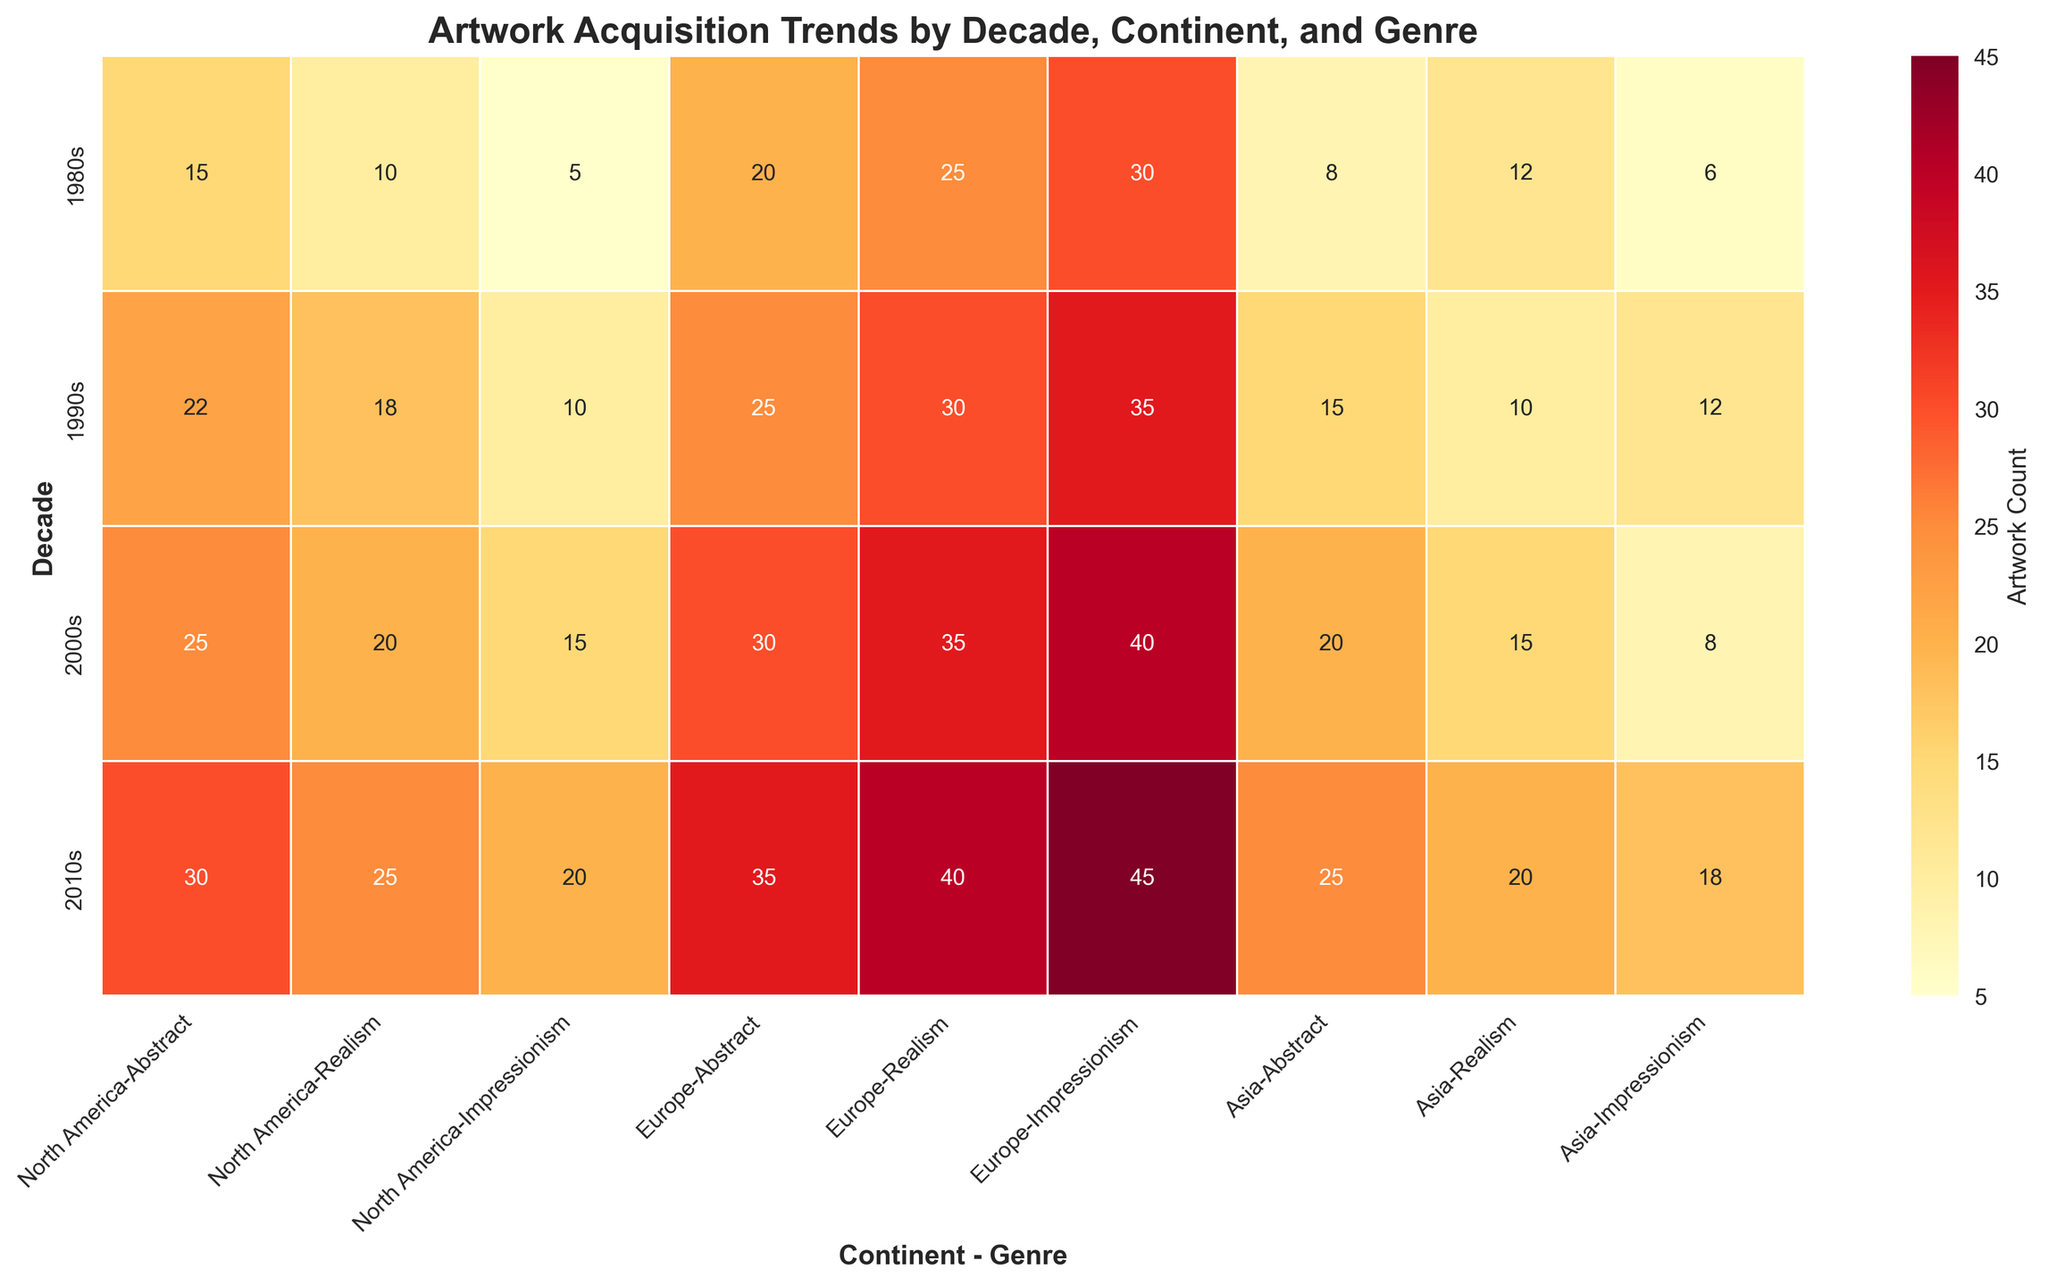What's the title of the figure? The title is typically located at the top of the figure and summarizes the content. In this case, it provides details on what the figure represents.
Answer: Artwork Acquisition Trends by Decade, Continent, and Genre What is the count of Abstract artworks acquired from North America in the 2000s? Locate the intersection of the "2000s" row and "North America - Abstract" column, and read the value.
Answer: 25 Which continent had the highest number of Realism artworks acquired in the 2010s? Compare the values in the "2010s" row under the Realism genre for each continent: North America, Europe, and Asia. The highest value is under Europe.
Answer: Europe How did the acquisition of Impressionism artworks in Asia change from the 1980s to the 2010s? Observe the "Asia - Impressionism" column at the intersections with the "1980s" and "2010s" rows. Subtract the 1980s value from the 2010s value: 18 - 6.
Answer: Increased by 12 What's the total count of North American artworks acquired in the 1990s? Sum the values for "1990s" under "North America - Abstract," "North America - Realism," and "North America - Impressionism": 22 + 18 + 10.
Answer: 50 Which decade saw the highest acquisition of Impressionism artworks in Europe? Compare the values in the "Europe - Impressionism" column for all decades. The highest value is in the 2010s.
Answer: 2010s Did the acquisition of Realism artworks in Asia increase or decrease from the 1990s to the 2000s? Compare the value in "Asia - Realism" for the 1990s and 2000s. The value decreased from 10 to 15.
Answer: Increase What is the average count of Abstract artworks acquired in the 1990s across all continents? Sum the values for "Abstract" in the 1990s across North America, Europe, and Asia, then divide by 3: (22 + 25 + 15) / 3.
Answer: 20.67 Which genre had the most consistent acquisition trend across all continents in the 2000s? Look at the "2000s" row and observe the variation in values for "Abstract," "Realism," and "Impressionism" across the continents. "Realism" shows more consistency compared to the other genres.
Answer: Realism 